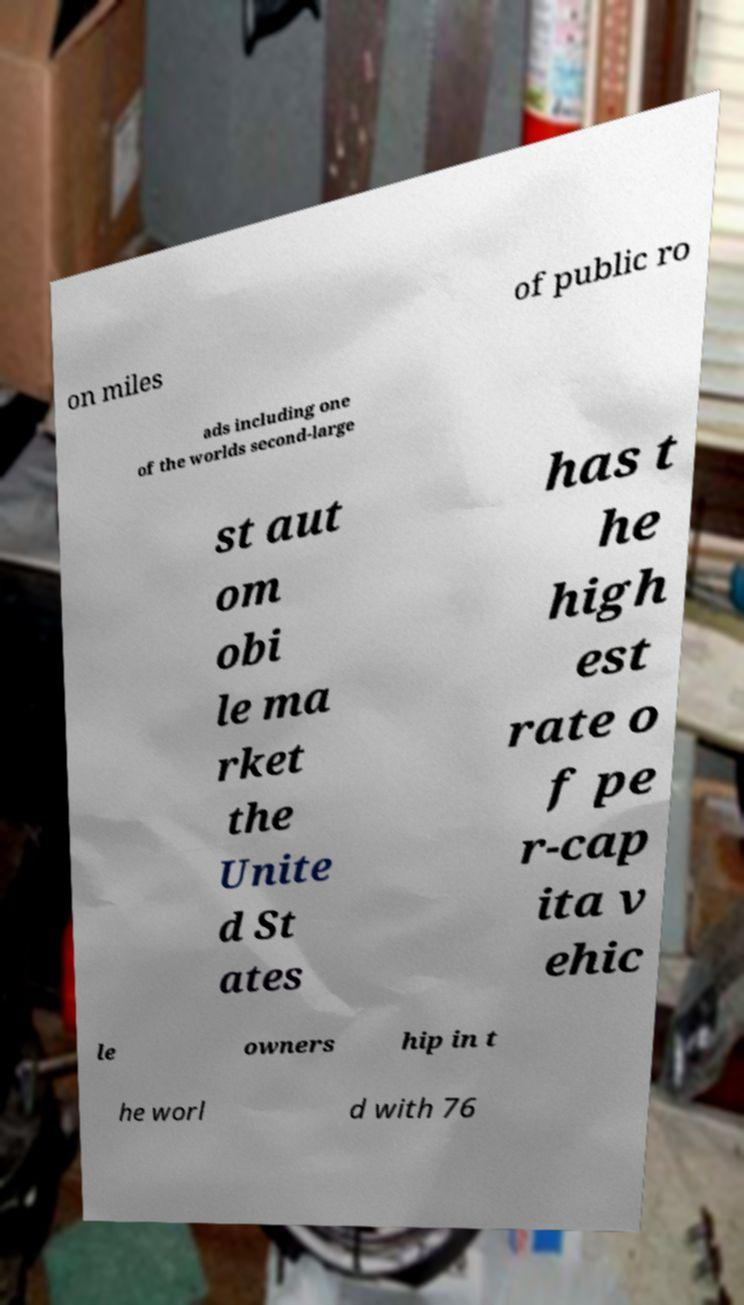Could you assist in decoding the text presented in this image and type it out clearly? on miles of public ro ads including one of the worlds second-large st aut om obi le ma rket the Unite d St ates has t he high est rate o f pe r-cap ita v ehic le owners hip in t he worl d with 76 